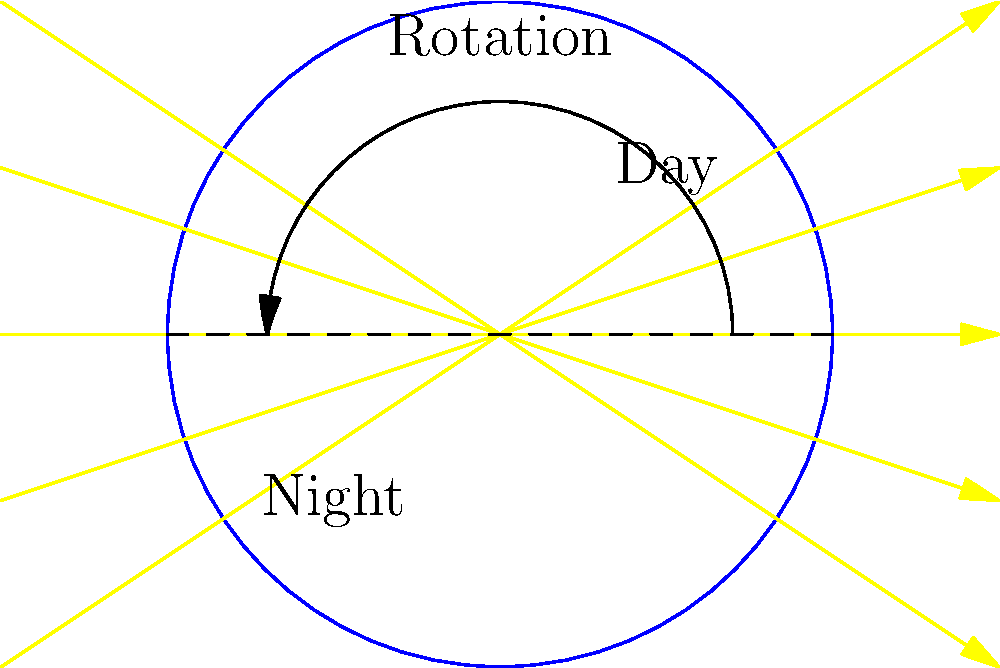In the golden era of Kannada cinema, many films showcased the beauty of day and night scenes. If we compare Earth's rotation to a film reel, how would you explain the transition from day to night using the spherical Earth model shown in the diagram? Let's break this down step-by-step, imagining Earth's rotation as a cosmic film reel:

1. Earth's shape: The diagram shows Earth as a sphere, which is an accurate representation for this explanation.

2. Sun's position: The yellow arrows represent sunlight coming from the left side of the image. This is analogous to a spotlight illuminating a film set.

3. Day and night division: The dashed line through the center of Earth divides the illuminated (day) and dark (night) sides.

4. Rotation: The curved arrow at the top indicates Earth's rotation from west to east (counterclockwise in this view), similar to a film reel moving frames.

5. Day side: The right half of Earth facing the Sun is experiencing daylight, much like a well-lit scene in a movie.

6. Night side: The left half of Earth away from the Sun is in darkness, reminiscent of a night scene in cinema.

7. Transition: As Earth rotates, a given point on its surface moves from the dark side to the light side (sunrise) and eventually back to the dark side (sunset). This is similar to how different scenes transition in a film.

8. Continuous cycle: Just as a film reel loops, Earth's rotation creates a continuous cycle of day and night.

This model explains why we experience day and night, and how the transition occurs due to Earth's rotation, much like how different scenes in a movie transition as the film reel moves.
Answer: Earth's rotation causes day-night cycle by moving locations in and out of sunlight. 